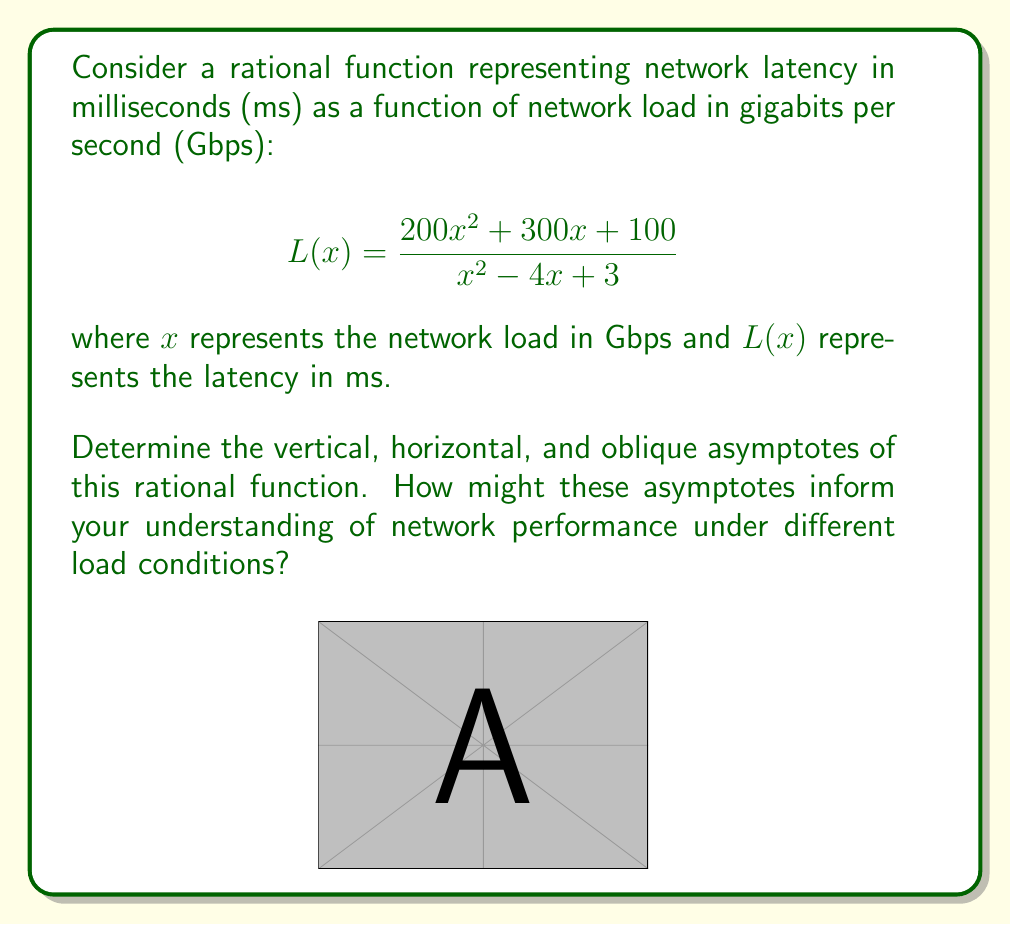Can you answer this question? Let's approach this step-by-step:

1) Vertical Asymptotes:
   Vertical asymptotes occur where the denominator equals zero.
   Solve $x^2 - 4x + 3 = 0$
   $(x - 1)(x - 3) = 0$
   $x = 1$ or $x = 3$
   So, vertical asymptotes occur at $x = 1$ and $x = 3$.

2) Horizontal Asymptote:
   Compare the degrees of the numerator and denominator.
   Both are quadratic (degree 2), so we divide the leading coefficients:
   $\lim_{x \to \infty} \frac{200x^2}{x^2} = 200$
   The horizontal asymptote is $y = 200$.

3) Oblique Asymptote:
   Since the degree of the numerator equals the degree of the denominator, there is no oblique asymptote.

4) Interpretation:
   - Vertical asymptotes at $x = 1$ and $x = 3$ Gbps suggest critical network loads where latency spikes dramatically.
   - The horizontal asymptote at $y = 200$ ms indicates a theoretical maximum latency as network load increases infinitely.
   - The absence of an oblique asymptote implies that latency doesn't grow linearly with load at high values.

This analysis helps identify potential network bottlenecks and performance limits, crucial for optimizing web security and user experience.
Answer: Vertical asymptotes: $x = 1, x = 3$
Horizontal asymptote: $y = 200$
Oblique asymptote: None 